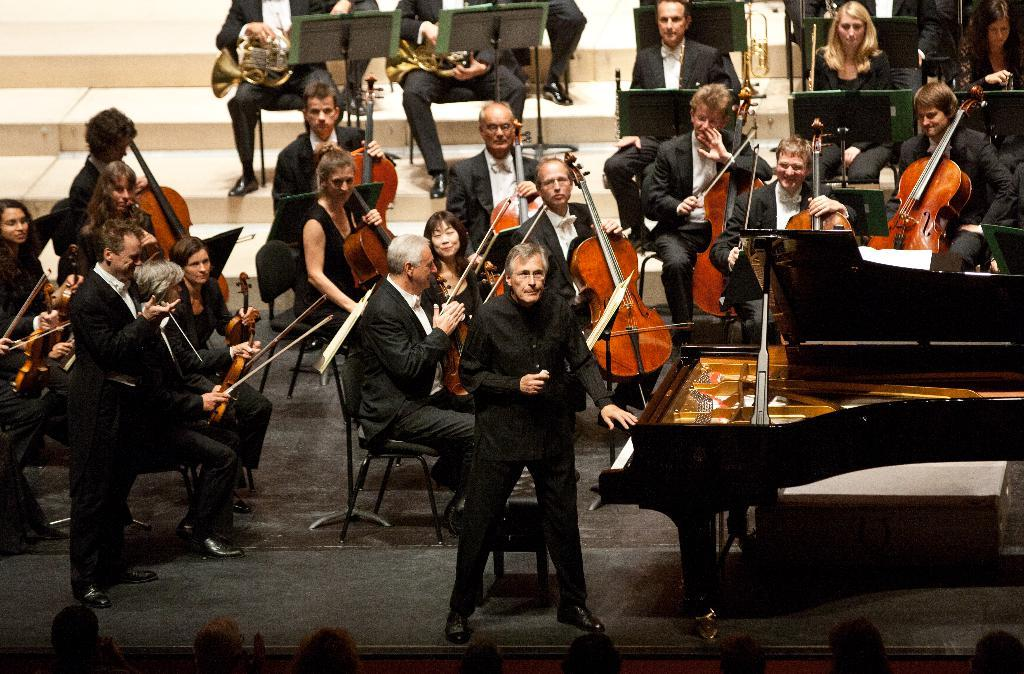What type of instruments are being played by the group of people in the image? There is a group of people playing violins and saxophones in the image. Can you describe the person standing in front of a piano? One person is standing in front of a piano in the image. What is the position of the other person in the image? Another person is standing in the image. What type of bun is being used to play the saxophone in the image? There is no bun present in the image, and saxophones are not played with buns. What sound does the alarm make in the image? There is no alarm present in the image, so it cannot make any sound. 